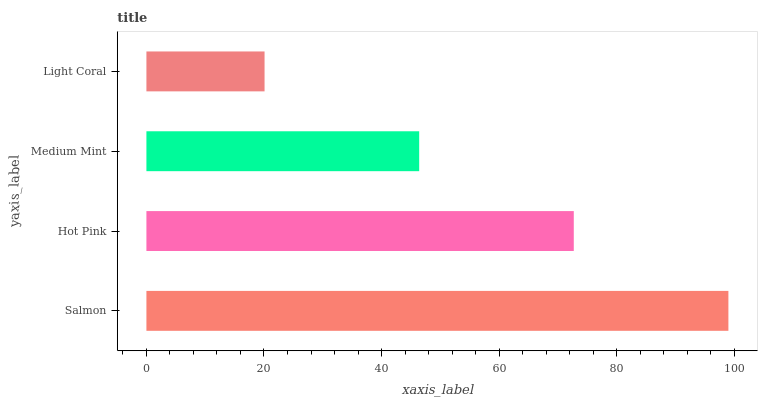Is Light Coral the minimum?
Answer yes or no. Yes. Is Salmon the maximum?
Answer yes or no. Yes. Is Hot Pink the minimum?
Answer yes or no. No. Is Hot Pink the maximum?
Answer yes or no. No. Is Salmon greater than Hot Pink?
Answer yes or no. Yes. Is Hot Pink less than Salmon?
Answer yes or no. Yes. Is Hot Pink greater than Salmon?
Answer yes or no. No. Is Salmon less than Hot Pink?
Answer yes or no. No. Is Hot Pink the high median?
Answer yes or no. Yes. Is Medium Mint the low median?
Answer yes or no. Yes. Is Salmon the high median?
Answer yes or no. No. Is Salmon the low median?
Answer yes or no. No. 